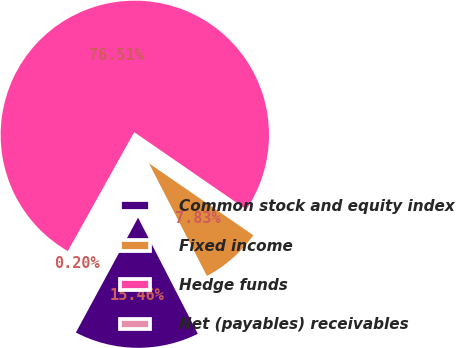Convert chart. <chart><loc_0><loc_0><loc_500><loc_500><pie_chart><fcel>Common stock and equity index<fcel>Fixed income<fcel>Hedge funds<fcel>Net (payables) receivables<nl><fcel>15.46%<fcel>7.83%<fcel>76.5%<fcel>0.2%<nl></chart> 